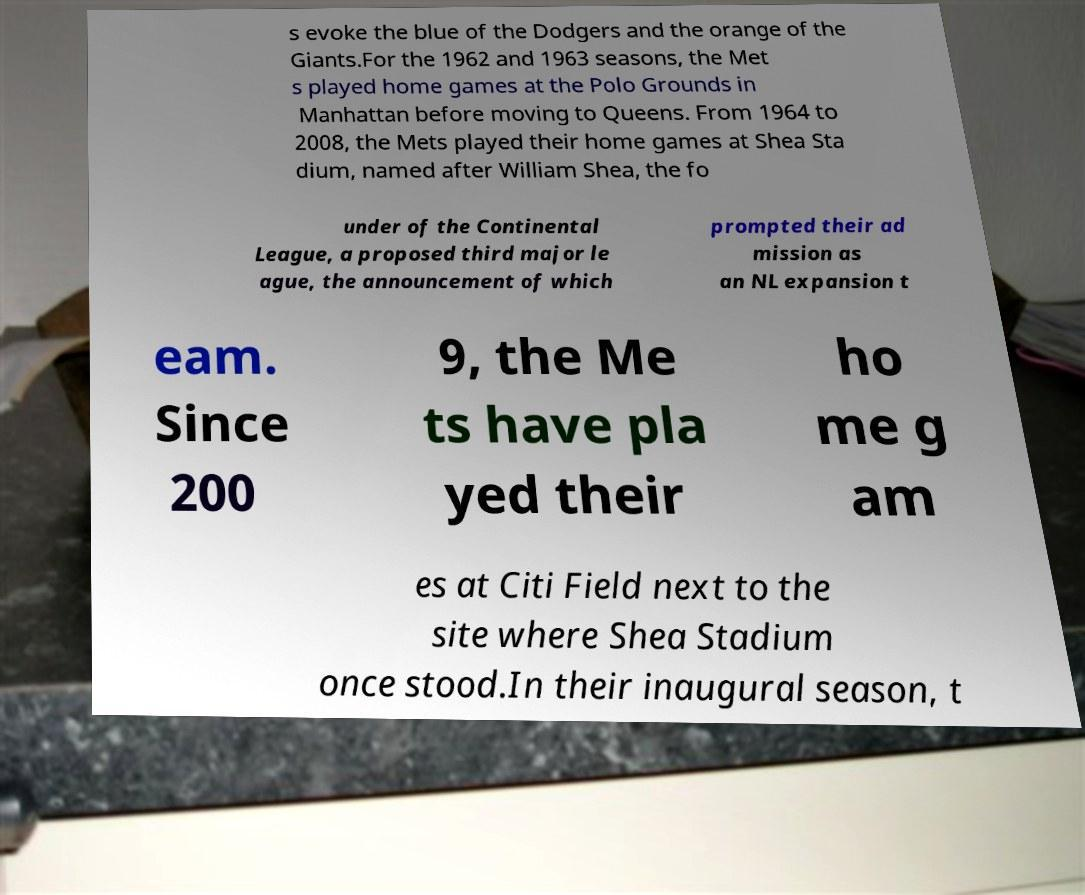Can you read and provide the text displayed in the image?This photo seems to have some interesting text. Can you extract and type it out for me? s evoke the blue of the Dodgers and the orange of the Giants.For the 1962 and 1963 seasons, the Met s played home games at the Polo Grounds in Manhattan before moving to Queens. From 1964 to 2008, the Mets played their home games at Shea Sta dium, named after William Shea, the fo under of the Continental League, a proposed third major le ague, the announcement of which prompted their ad mission as an NL expansion t eam. Since 200 9, the Me ts have pla yed their ho me g am es at Citi Field next to the site where Shea Stadium once stood.In their inaugural season, t 